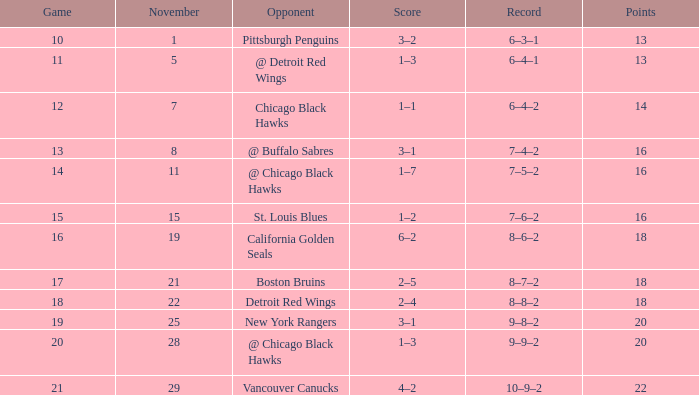What is the highest November that has a game less than 12, and @ detroit red wings as the opponent? 5.0. 